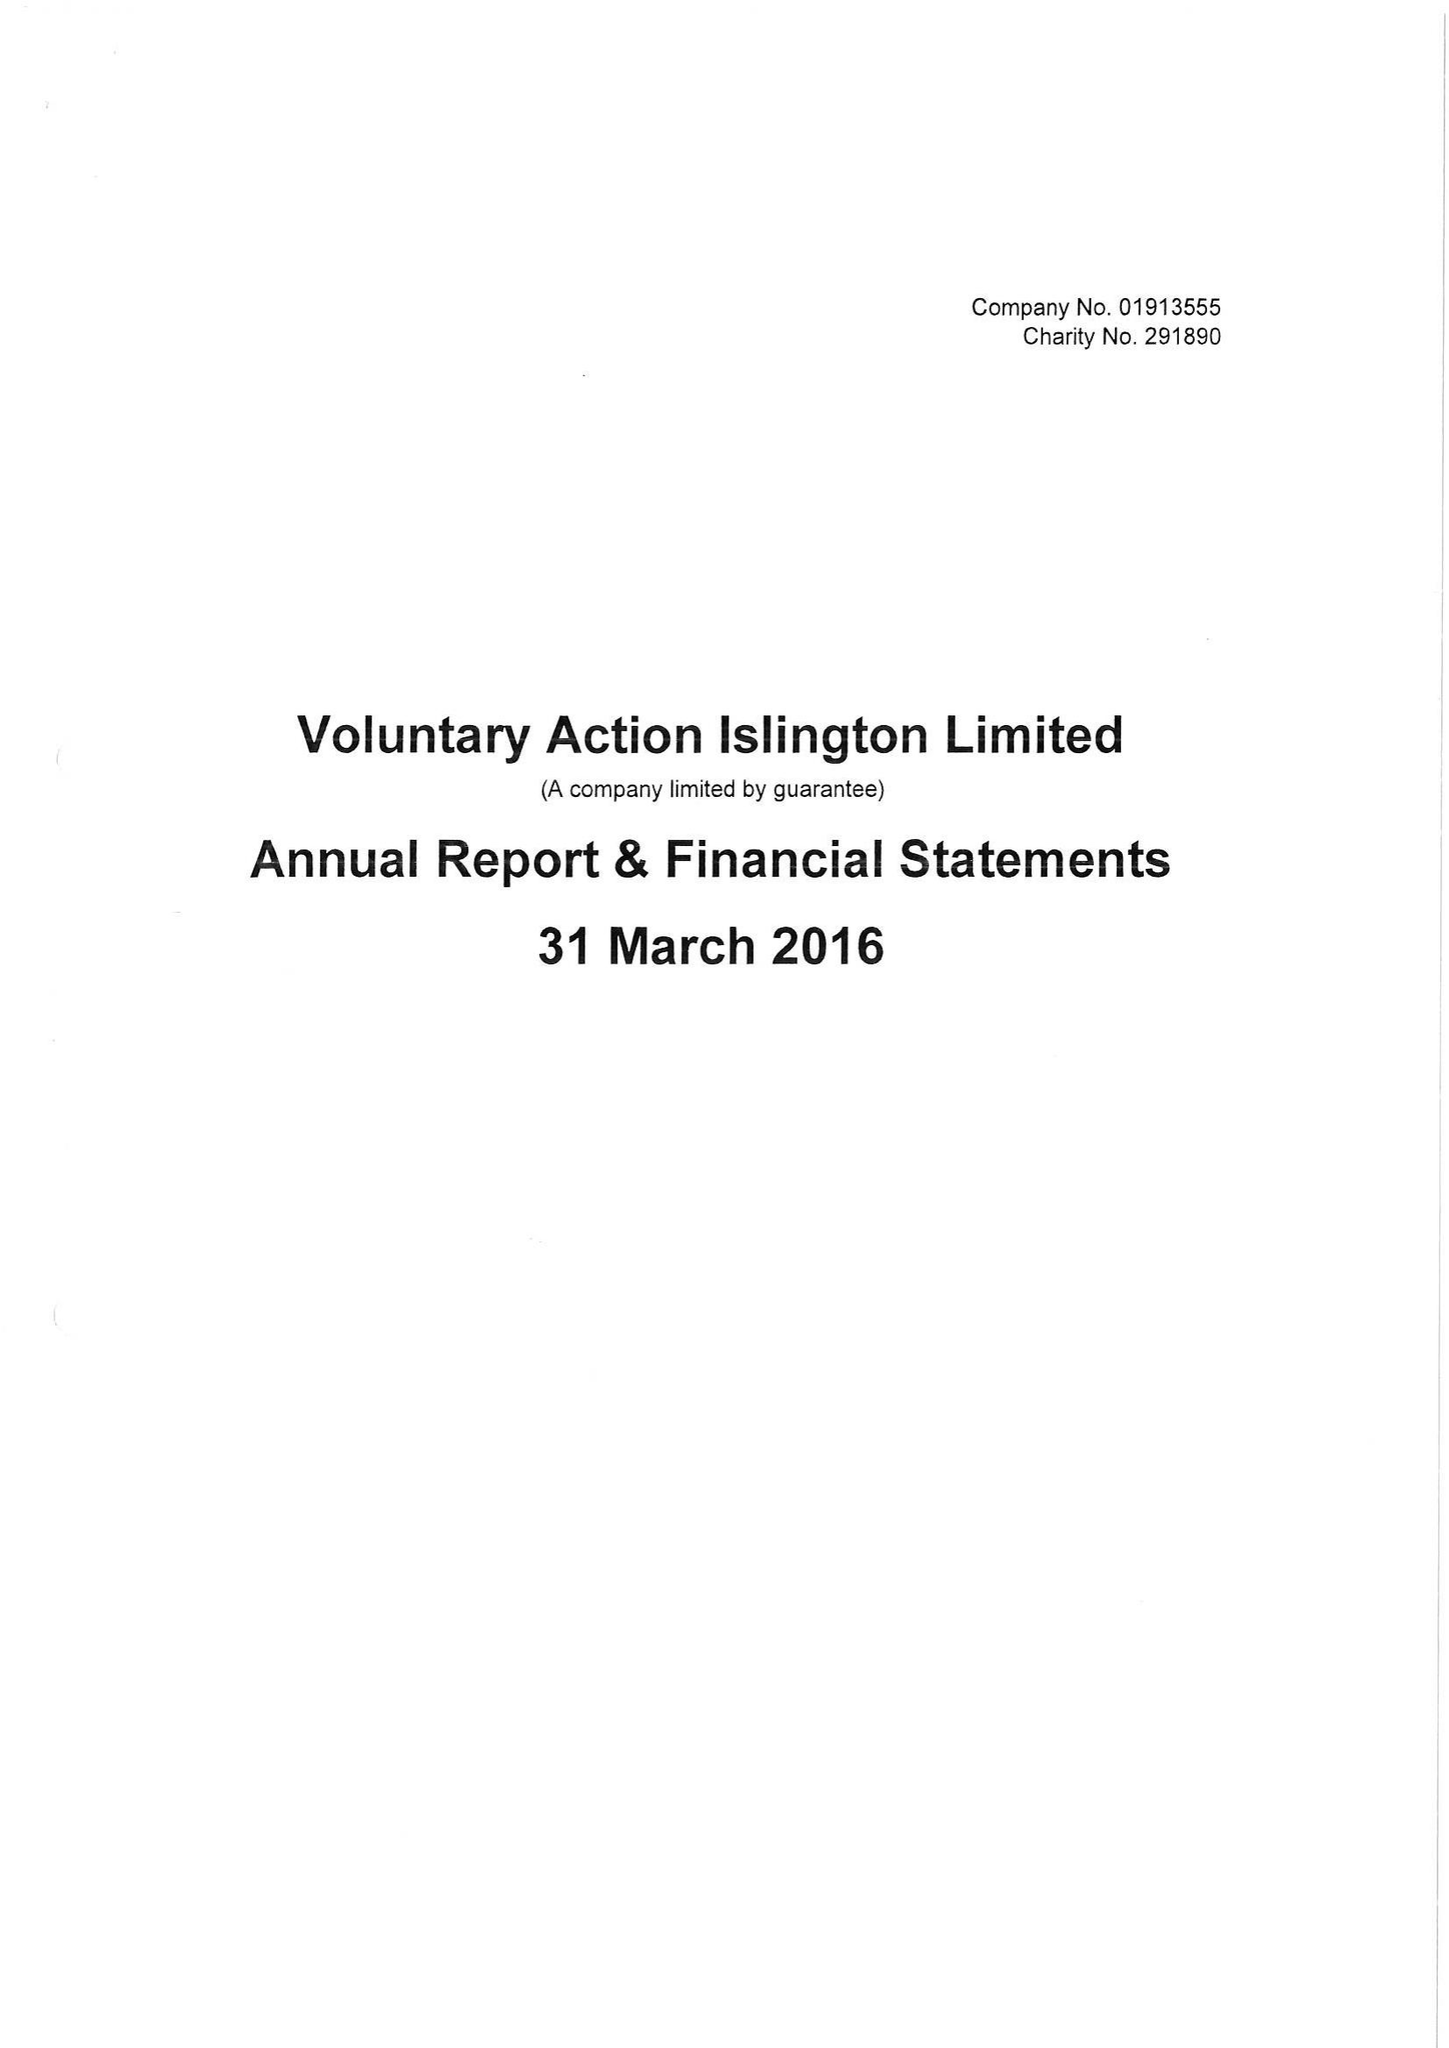What is the value for the charity_number?
Answer the question using a single word or phrase. 291890 